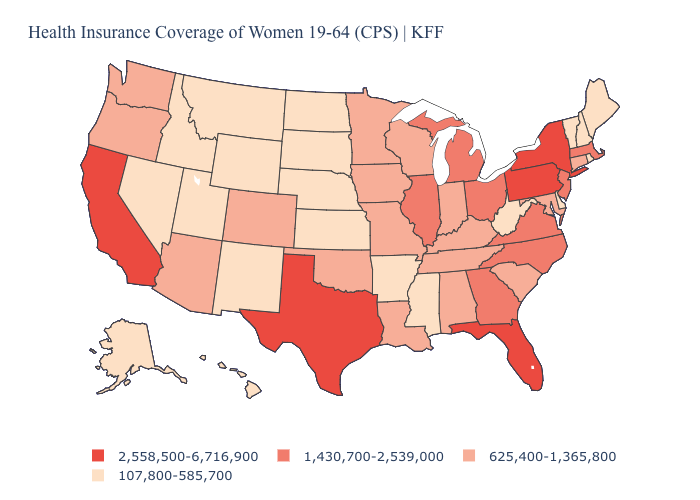Among the states that border Colorado , which have the highest value?
Quick response, please. Arizona, Oklahoma. Which states have the lowest value in the West?
Give a very brief answer. Alaska, Hawaii, Idaho, Montana, Nevada, New Mexico, Utah, Wyoming. Name the states that have a value in the range 107,800-585,700?
Write a very short answer. Alaska, Arkansas, Delaware, Hawaii, Idaho, Kansas, Maine, Mississippi, Montana, Nebraska, Nevada, New Hampshire, New Mexico, North Dakota, Rhode Island, South Dakota, Utah, Vermont, West Virginia, Wyoming. Among the states that border New York , does Vermont have the lowest value?
Answer briefly. Yes. What is the highest value in states that border Mississippi?
Keep it brief. 625,400-1,365,800. What is the value of North Dakota?
Short answer required. 107,800-585,700. Does Georgia have the same value as New York?
Keep it brief. No. What is the value of Delaware?
Short answer required. 107,800-585,700. Does New Hampshire have the lowest value in the Northeast?
Concise answer only. Yes. What is the value of Delaware?
Concise answer only. 107,800-585,700. Does Hawaii have the lowest value in the USA?
Short answer required. Yes. Name the states that have a value in the range 625,400-1,365,800?
Concise answer only. Alabama, Arizona, Colorado, Connecticut, Indiana, Iowa, Kentucky, Louisiana, Maryland, Minnesota, Missouri, Oklahoma, Oregon, South Carolina, Tennessee, Washington, Wisconsin. Does Rhode Island have the lowest value in the USA?
Answer briefly. Yes. Name the states that have a value in the range 107,800-585,700?
Short answer required. Alaska, Arkansas, Delaware, Hawaii, Idaho, Kansas, Maine, Mississippi, Montana, Nebraska, Nevada, New Hampshire, New Mexico, North Dakota, Rhode Island, South Dakota, Utah, Vermont, West Virginia, Wyoming. Which states hav the highest value in the West?
Quick response, please. California. 